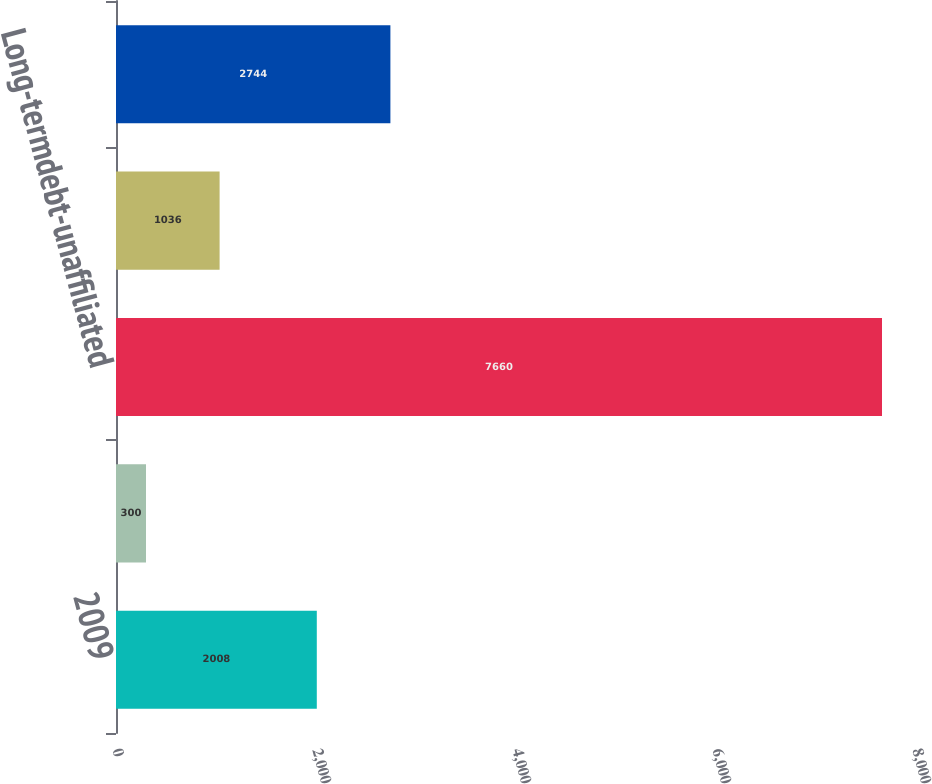Convert chart to OTSL. <chart><loc_0><loc_0><loc_500><loc_500><bar_chart><fcel>2009<fcel>Short-termdebt -<fcel>Long-termdebt-unaffiliated<fcel>Long-termdebt-affiliated 500<fcel>Unnamed: 4<nl><fcel>2008<fcel>300<fcel>7660<fcel>1036<fcel>2744<nl></chart> 